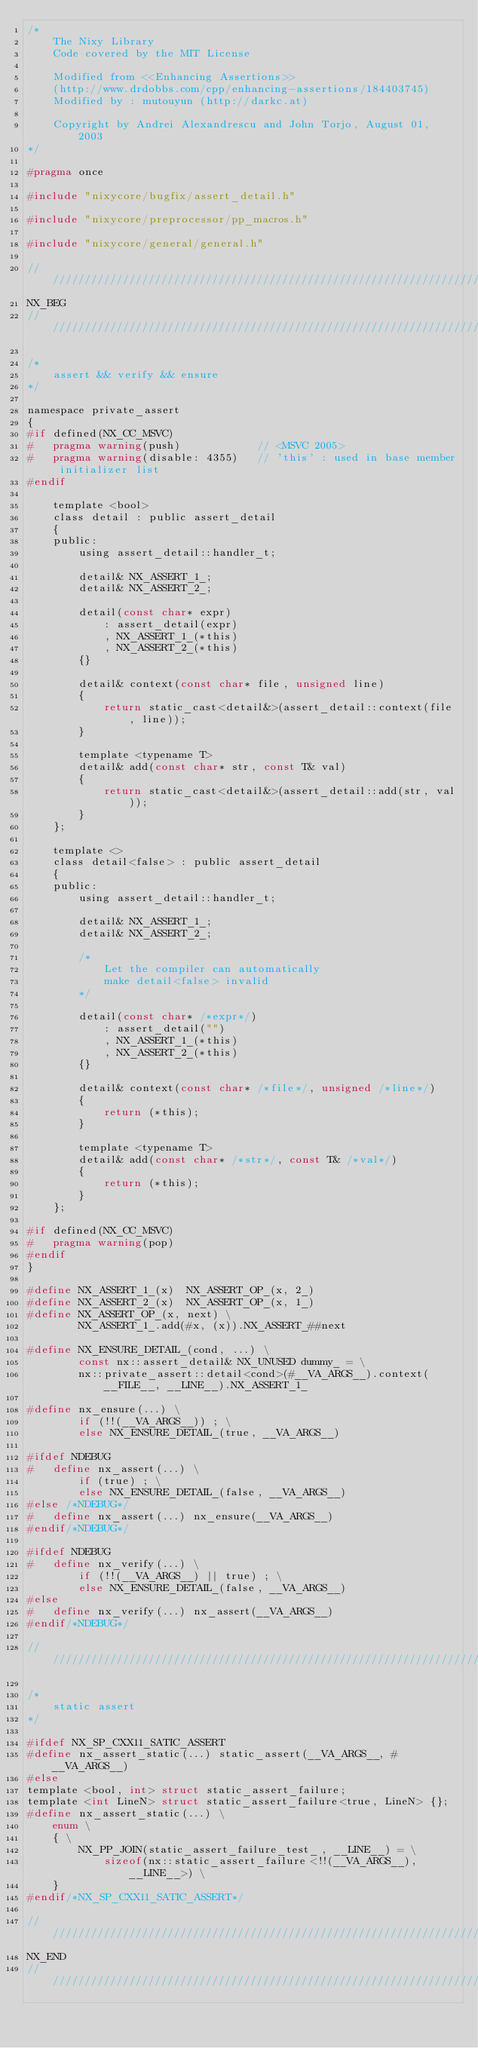Convert code to text. <code><loc_0><loc_0><loc_500><loc_500><_C_>/*
    The Nixy Library
    Code covered by the MIT License

    Modified from <<Enhancing Assertions>>
    (http://www.drdobbs.com/cpp/enhancing-assertions/184403745)
    Modified by : mutouyun (http://darkc.at)

    Copyright by Andrei Alexandrescu and John Torjo, August 01, 2003
*/

#pragma once

#include "nixycore/bugfix/assert_detail.h"

#include "nixycore/preprocessor/pp_macros.h"

#include "nixycore/general/general.h"

//////////////////////////////////////////////////////////////////////////
NX_BEG
//////////////////////////////////////////////////////////////////////////

/*
    assert && verify && ensure
*/

namespace private_assert
{
#if defined(NX_CC_MSVC)
#   pragma warning(push)            // <MSVC 2005>
#   pragma warning(disable: 4355)   // 'this' : used in base member initializer list
#endif

    template <bool>
    class detail : public assert_detail
    {
    public:
        using assert_detail::handler_t;

        detail& NX_ASSERT_1_;
        detail& NX_ASSERT_2_;

        detail(const char* expr)
            : assert_detail(expr)
            , NX_ASSERT_1_(*this)
            , NX_ASSERT_2_(*this)
        {}

        detail& context(const char* file, unsigned line)
        {
            return static_cast<detail&>(assert_detail::context(file, line));
        }

        template <typename T>
        detail& add(const char* str, const T& val)
        {
            return static_cast<detail&>(assert_detail::add(str, val));
        }
    };

    template <>
    class detail<false> : public assert_detail
    {
    public:
        using assert_detail::handler_t;

        detail& NX_ASSERT_1_;
        detail& NX_ASSERT_2_;

        /*
            Let the compiler can automatically
            make detail<false> invalid
        */

        detail(const char* /*expr*/)
            : assert_detail("")
            , NX_ASSERT_1_(*this)
            , NX_ASSERT_2_(*this)
        {}

        detail& context(const char* /*file*/, unsigned /*line*/)
        {
            return (*this);
        }

        template <typename T>
        detail& add(const char* /*str*/, const T& /*val*/)
        {
            return (*this);
        }
    };

#if defined(NX_CC_MSVC)
#   pragma warning(pop)
#endif
}

#define NX_ASSERT_1_(x)  NX_ASSERT_OP_(x, 2_)
#define NX_ASSERT_2_(x)  NX_ASSERT_OP_(x, 1_)
#define NX_ASSERT_OP_(x, next) \
        NX_ASSERT_1_.add(#x, (x)).NX_ASSERT_##next

#define NX_ENSURE_DETAIL_(cond, ...) \
        const nx::assert_detail& NX_UNUSED dummy_ = \
        nx::private_assert::detail<cond>(#__VA_ARGS__).context(__FILE__, __LINE__).NX_ASSERT_1_

#define nx_ensure(...) \
        if (!!(__VA_ARGS__)) ; \
        else NX_ENSURE_DETAIL_(true, __VA_ARGS__)

#ifdef NDEBUG
#   define nx_assert(...) \
        if (true) ; \
        else NX_ENSURE_DETAIL_(false, __VA_ARGS__)
#else /*NDEBUG*/
#   define nx_assert(...) nx_ensure(__VA_ARGS__)
#endif/*NDEBUG*/

#ifdef NDEBUG
#   define nx_verify(...) \
        if (!!(__VA_ARGS__) || true) ; \
        else NX_ENSURE_DETAIL_(false, __VA_ARGS__)
#else
#   define nx_verify(...) nx_assert(__VA_ARGS__)
#endif/*NDEBUG*/

//////////////////////////////////////////////////////////////////////////

/*
    static assert
*/

#ifdef NX_SP_CXX11_SATIC_ASSERT
#define nx_assert_static(...) static_assert(__VA_ARGS__, #__VA_ARGS__)
#else
template <bool, int> struct static_assert_failure;
template <int LineN> struct static_assert_failure<true, LineN> {};
#define nx_assert_static(...) \
    enum \
    { \
        NX_PP_JOIN(static_assert_failure_test_, __LINE__) = \
            sizeof(nx::static_assert_failure<!!(__VA_ARGS__), __LINE__>) \
    }
#endif/*NX_SP_CXX11_SATIC_ASSERT*/

//////////////////////////////////////////////////////////////////////////
NX_END
//////////////////////////////////////////////////////////////////////////
</code> 